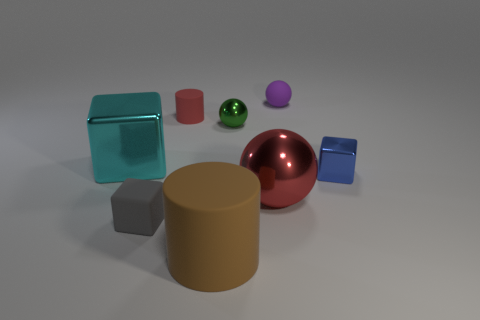Subtract all purple balls. How many balls are left? 2 Subtract all green balls. How many balls are left? 2 Subtract 2 cubes. How many cubes are left? 1 Add 1 gray matte blocks. How many objects exist? 9 Subtract all cylinders. How many objects are left? 6 Add 7 brown shiny cylinders. How many brown shiny cylinders exist? 7 Subtract 0 brown spheres. How many objects are left? 8 Subtract all brown cubes. Subtract all yellow cylinders. How many cubes are left? 3 Subtract all yellow spheres. How many blue cylinders are left? 0 Subtract all large rubber objects. Subtract all big matte cylinders. How many objects are left? 6 